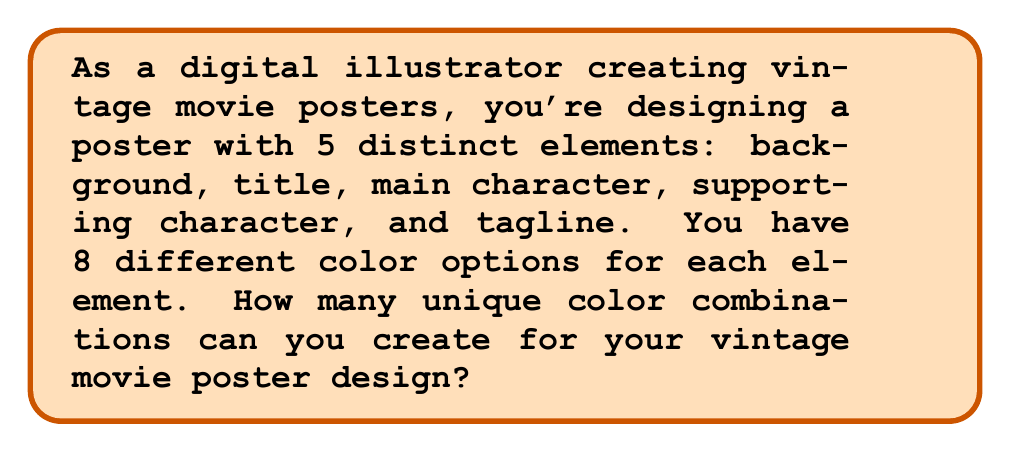Solve this math problem. Let's approach this step-by-step:

1) We have 5 distinct elements in the poster design:
   - Background
   - Title
   - Main character
   - Supporting character
   - Tagline

2) For each of these elements, we have 8 color options to choose from.

3) The color choice for each element is independent of the others. This means we can use the Multiplication Principle of Counting.

4) According to the Multiplication Principle, if we have a series of independent choices, where there are $n_1$ ways of making the first choice, $n_2$ ways of making the second choice, and so on up to $n_k$ ways of making the $k$-th choice, then the total number of ways to make all these choices is:

   $$ n_1 \times n_2 \times ... \times n_k $$

5) In our case, we have 5 choices (one for each element), and each choice has 8 options. So we have:

   $$ 8 \times 8 \times 8 \times 8 \times 8 $$

6) This can be written more concisely as:

   $$ 8^5 $$

7) Calculating this:

   $$ 8^5 = 8 \times 8 \times 8 \times 8 \times 8 = 32,768 $$

Therefore, you can create 32,768 unique color combinations for your vintage movie poster design.
Answer: $32,768$ 